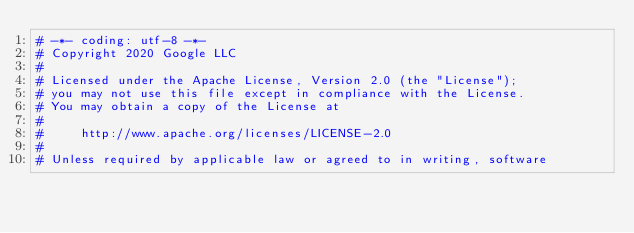Convert code to text. <code><loc_0><loc_0><loc_500><loc_500><_Python_># -*- coding: utf-8 -*-
# Copyright 2020 Google LLC
#
# Licensed under the Apache License, Version 2.0 (the "License");
# you may not use this file except in compliance with the License.
# You may obtain a copy of the License at
#
#     http://www.apache.org/licenses/LICENSE-2.0
#
# Unless required by applicable law or agreed to in writing, software</code> 